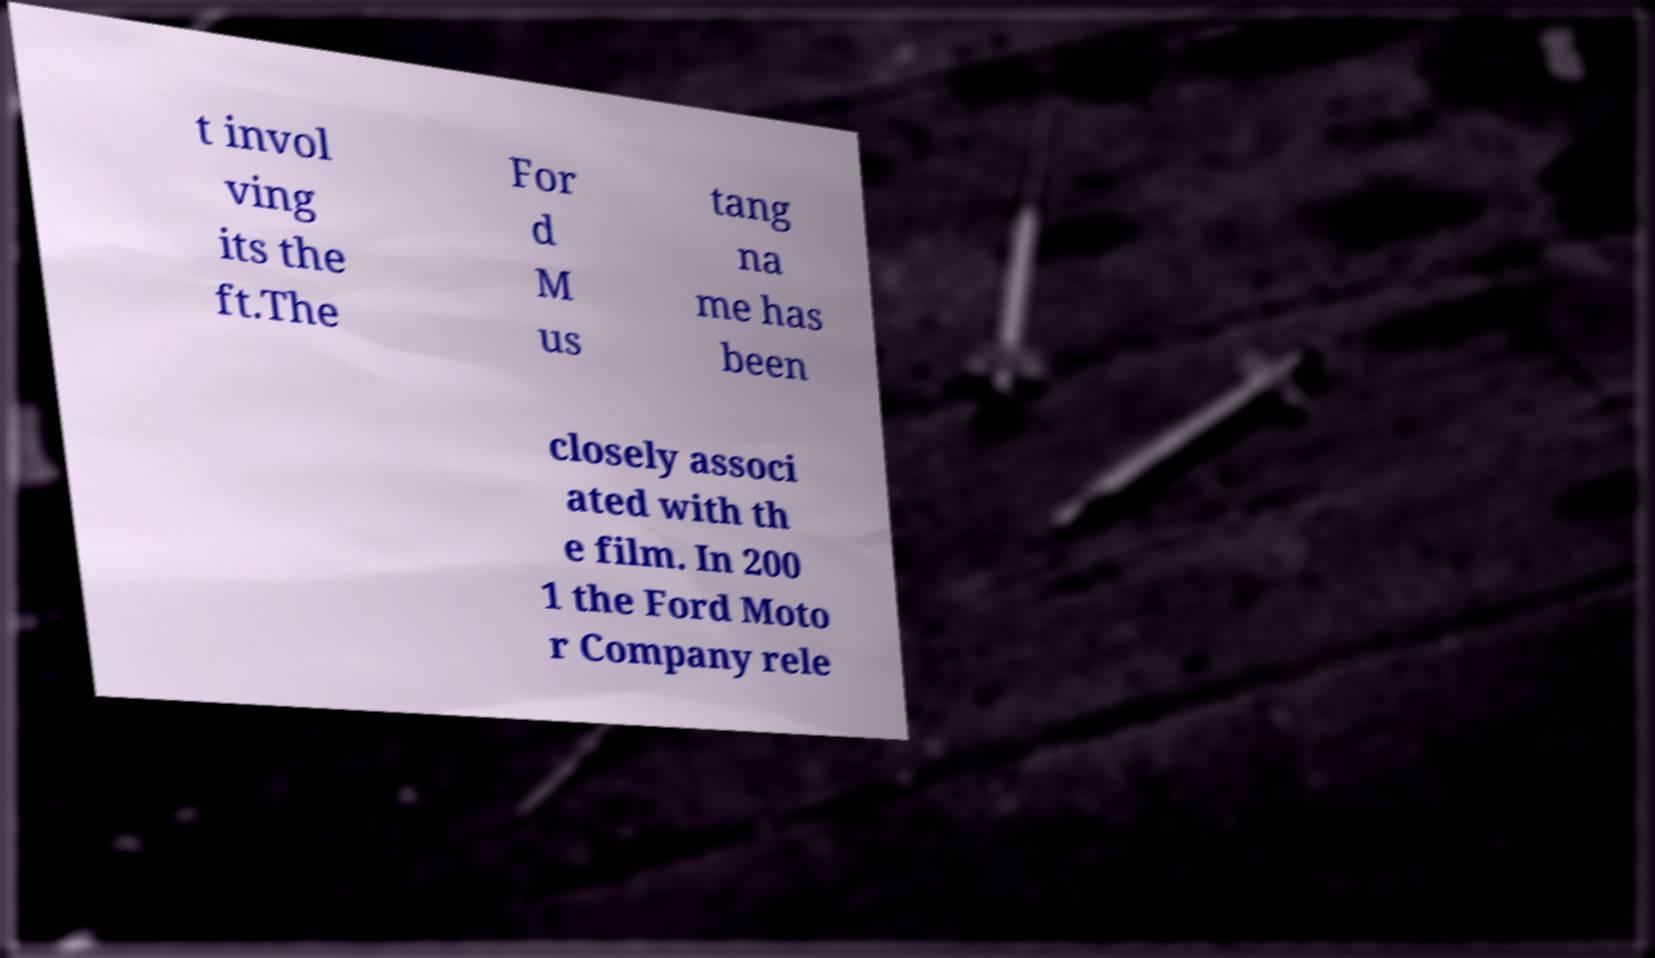Please read and relay the text visible in this image. What does it say? t invol ving its the ft.The For d M us tang na me has been closely associ ated with th e film. In 200 1 the Ford Moto r Company rele 